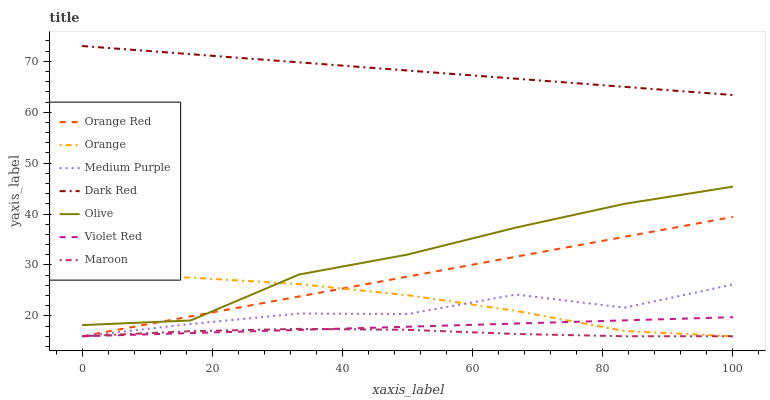Does Maroon have the minimum area under the curve?
Answer yes or no. Yes. Does Dark Red have the maximum area under the curve?
Answer yes or no. Yes. Does Dark Red have the minimum area under the curve?
Answer yes or no. No. Does Maroon have the maximum area under the curve?
Answer yes or no. No. Is Violet Red the smoothest?
Answer yes or no. Yes. Is Medium Purple the roughest?
Answer yes or no. Yes. Is Dark Red the smoothest?
Answer yes or no. No. Is Dark Red the roughest?
Answer yes or no. No. Does Violet Red have the lowest value?
Answer yes or no. Yes. Does Dark Red have the lowest value?
Answer yes or no. No. Does Dark Red have the highest value?
Answer yes or no. Yes. Does Maroon have the highest value?
Answer yes or no. No. Is Orange less than Dark Red?
Answer yes or no. Yes. Is Olive greater than Violet Red?
Answer yes or no. Yes. Does Olive intersect Orange?
Answer yes or no. Yes. Is Olive less than Orange?
Answer yes or no. No. Is Olive greater than Orange?
Answer yes or no. No. Does Orange intersect Dark Red?
Answer yes or no. No. 